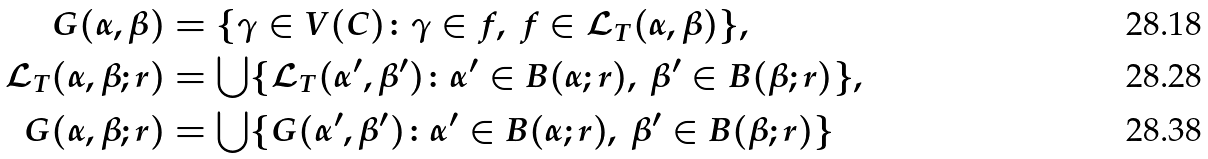Convert formula to latex. <formula><loc_0><loc_0><loc_500><loc_500>G ( \alpha , \beta ) & = \{ \gamma \in V ( C ) \colon \gamma \in f , \ f \in { \mathcal { L } } _ { T } ( \alpha , \beta ) \} , \\ { \mathcal { L } } _ { T } ( \alpha , \beta ; r ) & = \bigcup \{ { \mathcal { L } } _ { T } ( \alpha ^ { \prime } , \beta ^ { \prime } ) \colon \alpha ^ { \prime } \in B ( \alpha ; r ) , \ \beta ^ { \prime } \in B ( \beta ; r ) \} , \\ G ( \alpha , \beta ; r ) & = \bigcup \{ G ( \alpha ^ { \prime } , \beta ^ { \prime } ) \colon \alpha ^ { \prime } \in B ( \alpha ; r ) , \ \beta ^ { \prime } \in B ( \beta ; r ) \}</formula> 